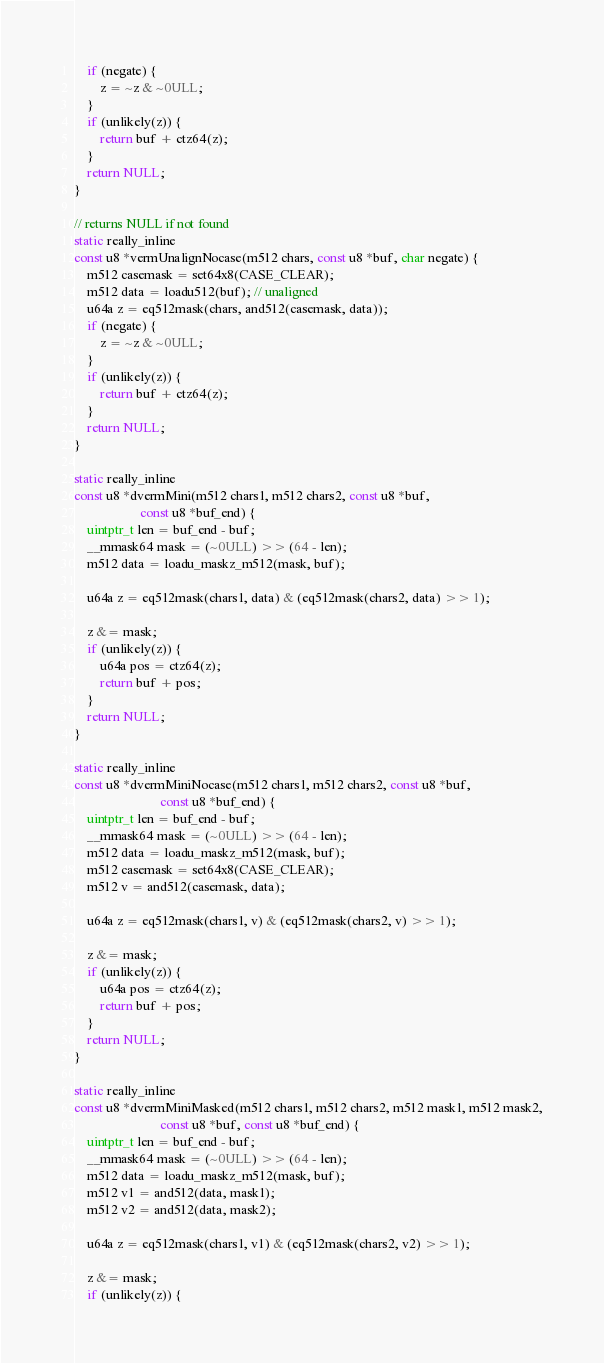<code> <loc_0><loc_0><loc_500><loc_500><_C_>    if (negate) {
        z = ~z & ~0ULL;
    }
    if (unlikely(z)) {
        return buf + ctz64(z);
    }
    return NULL;
}

// returns NULL if not found
static really_inline
const u8 *vermUnalignNocase(m512 chars, const u8 *buf, char negate) {
    m512 casemask = set64x8(CASE_CLEAR);
    m512 data = loadu512(buf); // unaligned
    u64a z = eq512mask(chars, and512(casemask, data));
    if (negate) {
        z = ~z & ~0ULL;
    }
    if (unlikely(z)) {
        return buf + ctz64(z);
    }
    return NULL;
}

static really_inline
const u8 *dvermMini(m512 chars1, m512 chars2, const u8 *buf,
                    const u8 *buf_end) {
    uintptr_t len = buf_end - buf;
    __mmask64 mask = (~0ULL) >> (64 - len);
    m512 data = loadu_maskz_m512(mask, buf);

    u64a z = eq512mask(chars1, data) & (eq512mask(chars2, data) >> 1);

    z &= mask;
    if (unlikely(z)) {
        u64a pos = ctz64(z);
        return buf + pos;
    }
    return NULL;
}

static really_inline
const u8 *dvermMiniNocase(m512 chars1, m512 chars2, const u8 *buf,
                          const u8 *buf_end) {
    uintptr_t len = buf_end - buf;
    __mmask64 mask = (~0ULL) >> (64 - len);
    m512 data = loadu_maskz_m512(mask, buf);
    m512 casemask = set64x8(CASE_CLEAR);
    m512 v = and512(casemask, data);

    u64a z = eq512mask(chars1, v) & (eq512mask(chars2, v) >> 1);

    z &= mask;
    if (unlikely(z)) {
        u64a pos = ctz64(z);
        return buf + pos;
    }
    return NULL;
}

static really_inline
const u8 *dvermMiniMasked(m512 chars1, m512 chars2, m512 mask1, m512 mask2,
                          const u8 *buf, const u8 *buf_end) {
    uintptr_t len = buf_end - buf;
    __mmask64 mask = (~0ULL) >> (64 - len);
    m512 data = loadu_maskz_m512(mask, buf);
    m512 v1 = and512(data, mask1);
    m512 v2 = and512(data, mask2);

    u64a z = eq512mask(chars1, v1) & (eq512mask(chars2, v2) >> 1);

    z &= mask;
    if (unlikely(z)) {</code> 